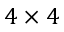Convert formula to latex. <formula><loc_0><loc_0><loc_500><loc_500>4 \times 4</formula> 